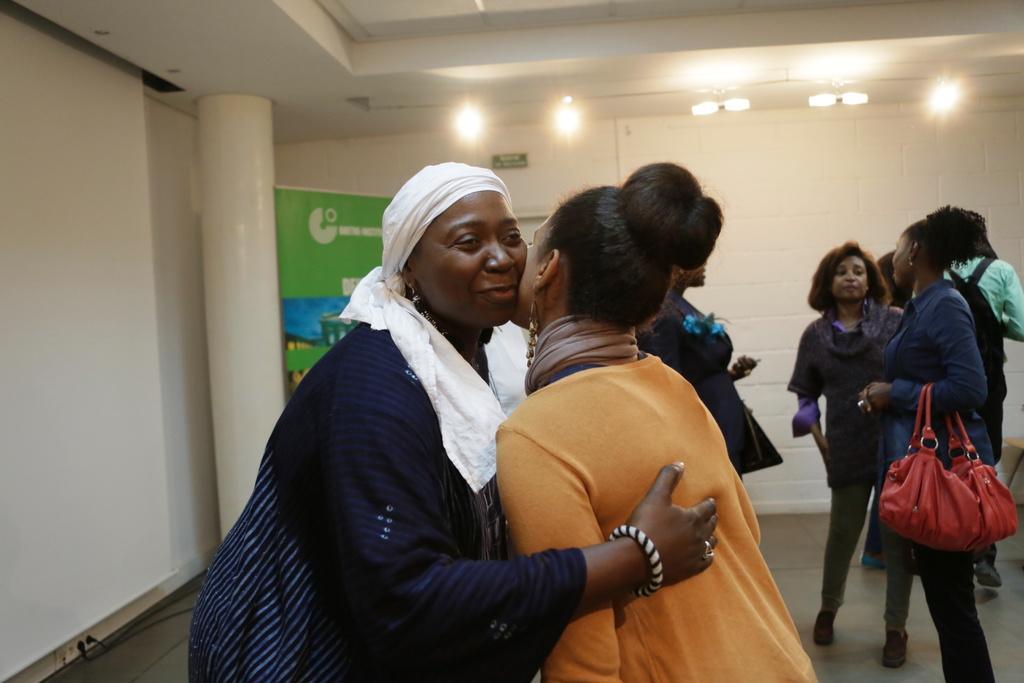Could you give a brief overview of what you see in this image? As we can see in the image there is a wall, banner, few people standing over here. 